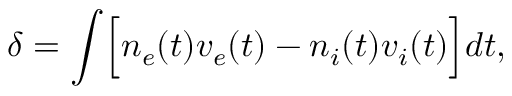Convert formula to latex. <formula><loc_0><loc_0><loc_500><loc_500>\delta = \int \left [ n _ { e } ( t ) v _ { e } ( t ) - n _ { i } ( t ) v _ { i } ( t ) \right ] d t ,</formula> 